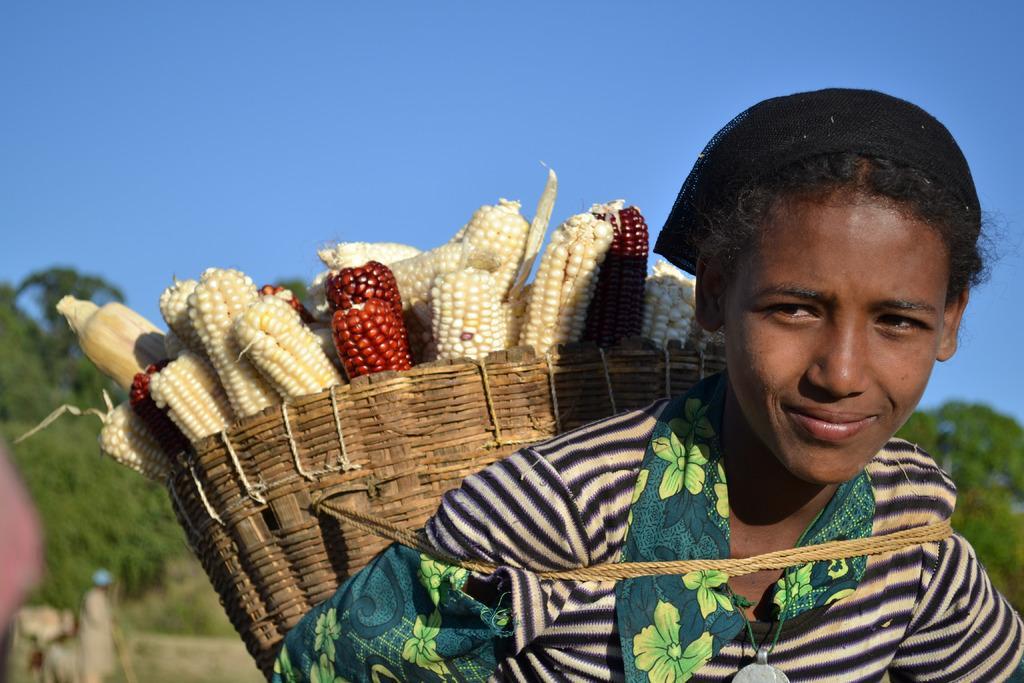Could you give a brief overview of what you see in this image? In this image in front there is a girl wearing the basket. Inside the basket there are sweet corns. In the background of the image there are trees and sky. 